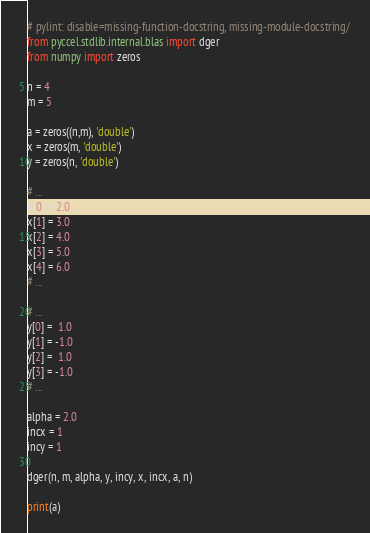Convert code to text. <code><loc_0><loc_0><loc_500><loc_500><_Python_># pylint: disable=missing-function-docstring, missing-module-docstring/
from pyccel.stdlib.internal.blas import dger
from numpy import zeros

n = 4
m = 5

a = zeros((n,m), 'double')
x = zeros(m, 'double')
y = zeros(n, 'double')

# ...
x[0] = 2.0
x[1] = 3.0
x[2] = 4.0
x[3] = 5.0
x[4] = 6.0
# ...

# ...
y[0] =  1.0
y[1] = -1.0
y[2] =  1.0
y[3] = -1.0
# ...

alpha = 2.0
incx = 1
incy = 1

dger(n, m, alpha, y, incy, x, incx, a, n)

print(a)
</code> 